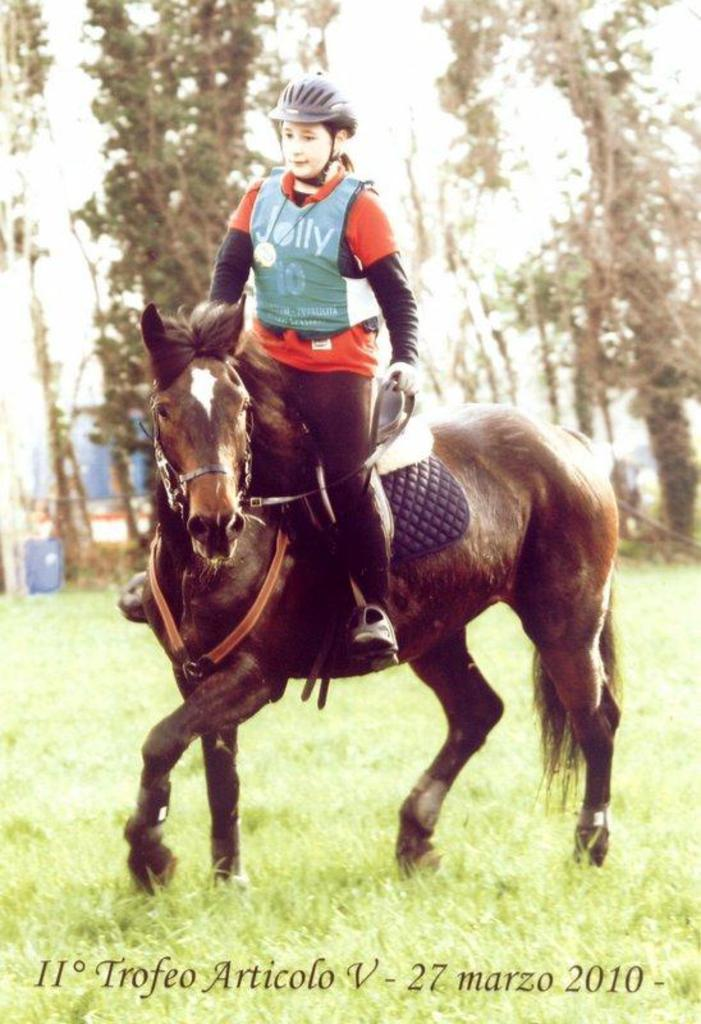What type of vegetation can be seen in the image? There are trees and grass in the image. What is the woman in the image doing? The woman is standing on a horse in the image. What color is the crayon that the woman is holding while standing on the horse? There is no crayon present in the image; the woman is standing on a horse without holding any crayons. 